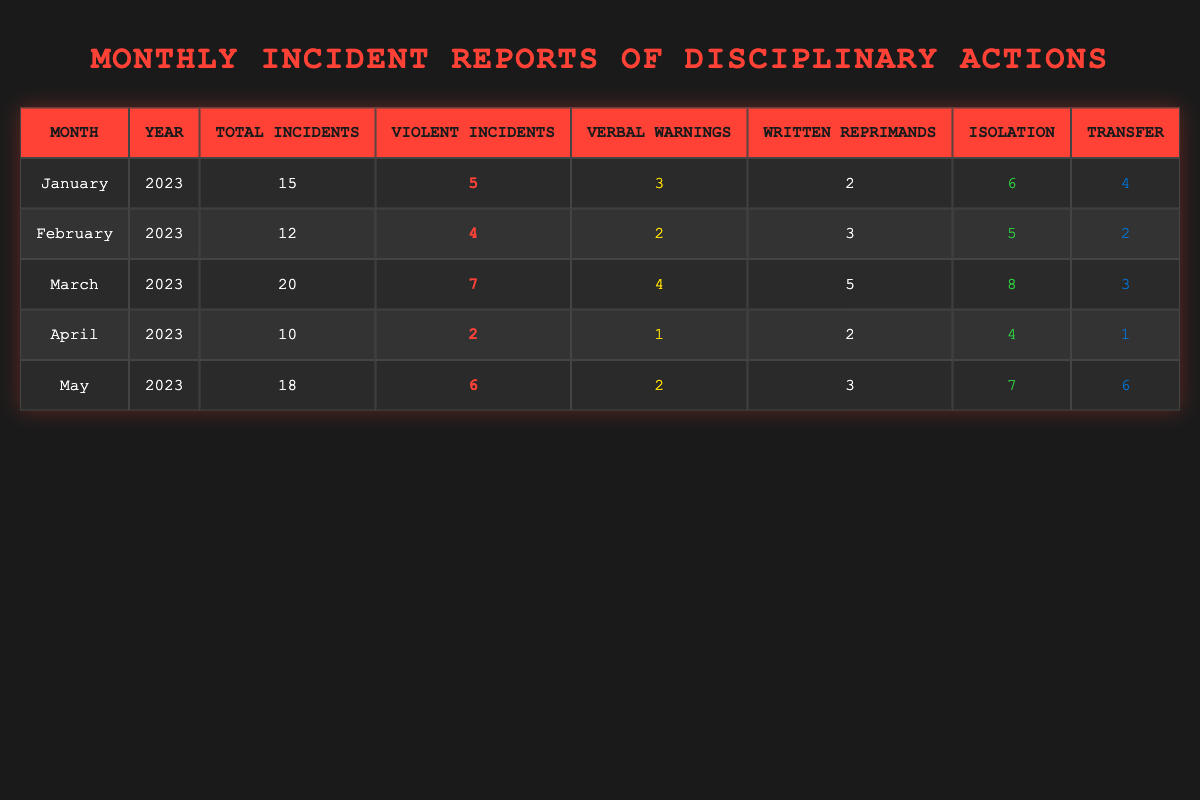What was the total number of incidents reported in March? In the table, the row for March shows a total of 20 incidents reported.
Answer: 20 How many violent incidents occurred in May? For May, the table indicates that there were 6 violent incidents.
Answer: 6 What is the average number of verbal warnings issued over these five months? To find the average, we sum the verbal warnings: 3 + 2 + 4 + 1 + 2 = 12. Then, we divide by the number of months (5), which gives 12 / 5 = 2.4.
Answer: 2.4 In which month was the highest number of disciplinary actions in isolation taken? Reviewing the table, March had the highest number of isolations at 8.
Answer: March True or False: February had more written reprimands than April. On comparing the rows, February had 3 written reprimands while April had 2, so the statement is true.
Answer: True What is the total number of incidents (violent and non-violent) for the first three months? The first three months' total incidents are January (15), February (12), and March (20). Adding these gives: 15 + 12 + 20 = 47.
Answer: 47 Which month had the lowest total number of incidents, and what was that number? Looking through the months, April shows the lowest total incidents at 10.
Answer: April, 10 Calculate the total number of transfers across all months. The total number of transfers can be calculated by adding the transfers across all months: 4 (Jan) + 2 (Feb) + 3 (Mar) + 1 (Apr) + 6 (May) = 16.
Answer: 16 True or False: The number of violent incidents decreased from January to April. January had 5 violent incidents, February had 4, March had 7, and April had 2. Analyzing these values, it is false that the number of violent incidents decreased throughout.
Answer: False 